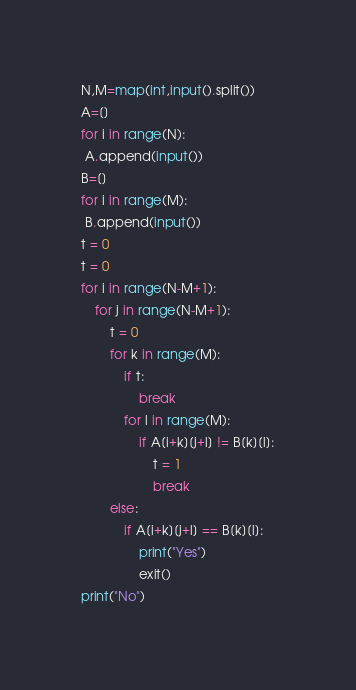<code> <loc_0><loc_0><loc_500><loc_500><_Python_>N,M=map(int,input().split())
A=[]
for i in range(N):
 A.append(input())
B=[]
for i in range(M):
 B.append(input())
t = 0
t = 0
for i in range(N-M+1):
	for j in range(N-M+1):
		t = 0
		for k in range(M):
			if t:
				break
			for l in range(M):
				if A[i+k][j+l] != B[k][l]:
					t = 1
					break
		else:
			if A[i+k][j+l] == B[k][l]:
				print("Yes")
				exit()
print("No")</code> 